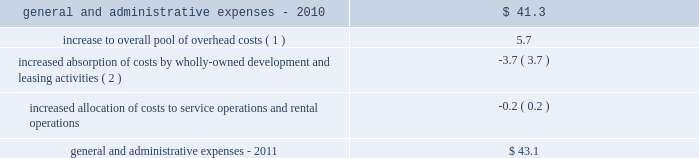32| | duke realty corporation annual report 2012 2022 in 2010 , we sold approximately 60 acres of land , in two separate transactions , which resulted in impairment charges of $ 9.8 million .
These sales were opportunistic in nature and we had not identified or actively marketed this land for disposition , as it was previously intended to be held for development .
General and administrative expenses general and administrative expenses increased from $ 41.3 million in 2010 to $ 43.1 million in 2011 .
The table sets forth the factors that led to the increase in general and administrative expenses from 2010 to 2011 ( in millions ) : .
Interest expense interest expense from continuing operations increased from $ 186.4 million in 2010 to $ 220.5 million in 2011 .
The increase was primarily a result of increased average outstanding debt during 2011 compared to 2010 , which was driven by our acquisition activities as well as other uses of capital .
A $ 7.2 million decrease in the capitalization of interest costs , the result of developed properties no longer meeting the criteria for interest capitalization , also contributed to the increase in interest expense .
Gain ( loss ) on debt transactions there were no gains or losses on debt transactions during 2011 .
During 2010 , through a cash tender offer and open market transactions , we repurchased certain of our outstanding series of unsecured notes scheduled to mature in 2011 and 2013 .
In total , we paid $ 292.2 million for unsecured notes that had a face value of $ 279.9 million .
We recognized a net loss on extinguishment of $ 16.3 million after considering the write-off of unamortized deferred financing costs , discounts and other accounting adjustments .
Acquisition-related activity during 2011 , we recognized approximately $ 2.3 million in acquisition costs , compared to $ 1.9 million of such costs in 2010 .
During 2011 , we also recognized a $ 1.1 million gain related to the acquisition of a building from one of our 50%-owned unconsolidated joint ventures , compared to a $ 57.7 million gain in 2010 on the acquisition of our joint venture partner 2019s 50% ( 50 % ) interest in dugan .
Critical accounting policies the preparation of our consolidated financial statements in conformity with gaap requires us to make estimates and assumptions that affect the reported amounts of assets and liabilities and disclosure of contingent assets and liabilities at the date of the financial statements and the reported amounts of revenues and expenses during the reported period .
Our estimates , judgments and assumptions are inherently subjective and based on the existing business and market conditions , and are therefore continually evaluated based upon available information and experience .
Note 2 to the consolidated financial statements includes further discussion of our significant accounting policies .
Our management has assessed the accounting policies used in the preparation of our financial statements and discussed them with our audit committee and independent auditors .
The following accounting policies are considered critical based upon materiality to the financial statements , degree of judgment involved in estimating reported amounts and sensitivity to changes in industry and economic conditions : ( 1 ) the increase to our overall pool of overhead costs from 2010 is largely due to increased severance pay related to overhead reductions that took place near the end of 2011 .
( 2 ) our total leasing activity increased and we also increased wholly owned development activities from 2010 .
We capitalized $ 25.3 million and $ 10.4 million of our total overhead costs to leasing and development , respectively , for consolidated properties during 2011 , compared to capitalizing $ 23.5 million and $ 8.5 million of such costs , respectively , for 2010 .
Combined overhead costs capitalized to leasing and development totaled 20.6% ( 20.6 % ) and 19.1% ( 19.1 % ) of our overall pool of overhead costs for 2011 and 2010 , respectively. .
What was the percent of the growth of the interest expense interest expense from continuing operations increased from 2010 to 2011? 
Computations: ((220.5 - 186.4) / 186.4)
Answer: 0.18294. 